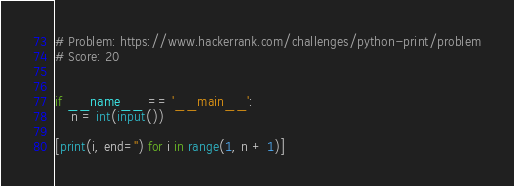Convert code to text. <code><loc_0><loc_0><loc_500><loc_500><_Python_># Problem: https://www.hackerrank.com/challenges/python-print/problem
# Score: 20


if __name__ == '__main__':
    n = int(input())

[print(i, end='') for i in range(1, n + 1)]
</code> 